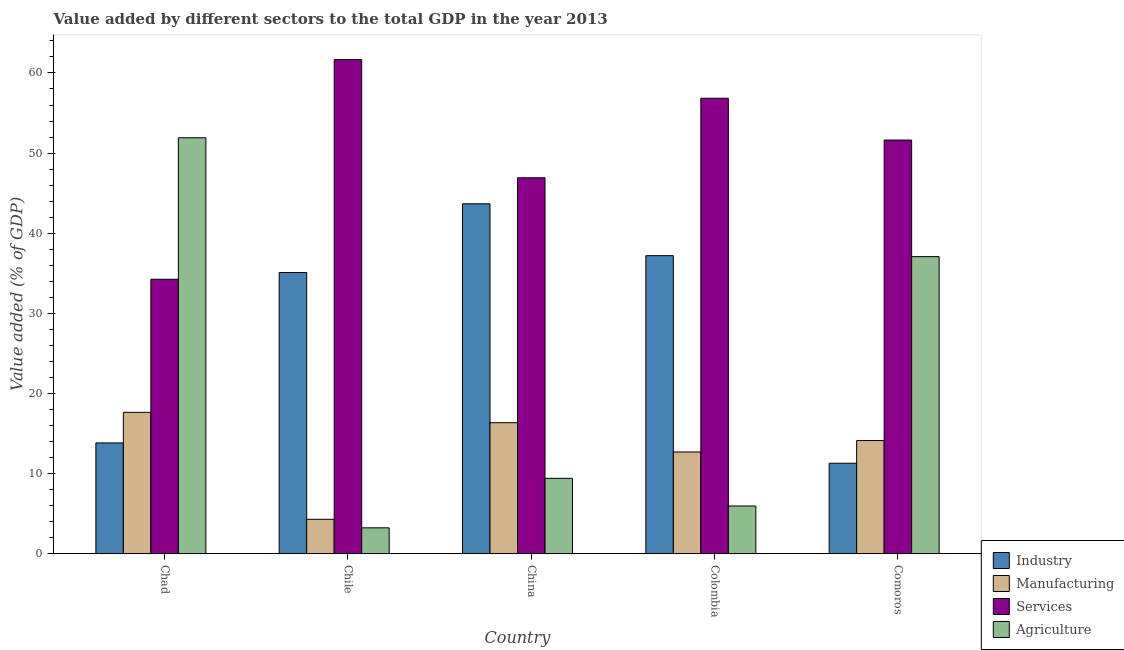How many different coloured bars are there?
Your answer should be very brief. 4. How many groups of bars are there?
Make the answer very short. 5. Are the number of bars per tick equal to the number of legend labels?
Provide a short and direct response. Yes. Are the number of bars on each tick of the X-axis equal?
Your answer should be very brief. Yes. How many bars are there on the 5th tick from the left?
Give a very brief answer. 4. How many bars are there on the 1st tick from the right?
Your response must be concise. 4. What is the value added by services sector in Comoros?
Your answer should be compact. 51.63. Across all countries, what is the maximum value added by services sector?
Keep it short and to the point. 61.67. Across all countries, what is the minimum value added by industrial sector?
Keep it short and to the point. 11.29. In which country was the value added by manufacturing sector maximum?
Provide a short and direct response. Chad. In which country was the value added by services sector minimum?
Give a very brief answer. Chad. What is the total value added by industrial sector in the graph?
Your response must be concise. 141.09. What is the difference between the value added by services sector in Chad and that in Comoros?
Your response must be concise. -17.37. What is the difference between the value added by agricultural sector in China and the value added by industrial sector in Comoros?
Offer a very short reply. -1.88. What is the average value added by manufacturing sector per country?
Ensure brevity in your answer.  13.02. What is the difference between the value added by agricultural sector and value added by manufacturing sector in Colombia?
Your answer should be compact. -6.74. What is the ratio of the value added by agricultural sector in Chile to that in Colombia?
Your answer should be compact. 0.54. Is the difference between the value added by manufacturing sector in China and Comoros greater than the difference between the value added by services sector in China and Comoros?
Your response must be concise. Yes. What is the difference between the highest and the second highest value added by services sector?
Provide a succinct answer. 4.83. What is the difference between the highest and the lowest value added by services sector?
Offer a terse response. 27.42. In how many countries, is the value added by manufacturing sector greater than the average value added by manufacturing sector taken over all countries?
Offer a terse response. 3. What does the 2nd bar from the left in Chad represents?
Give a very brief answer. Manufacturing. What does the 2nd bar from the right in Chad represents?
Ensure brevity in your answer.  Services. Is it the case that in every country, the sum of the value added by industrial sector and value added by manufacturing sector is greater than the value added by services sector?
Provide a succinct answer. No. How many bars are there?
Make the answer very short. 20. Are all the bars in the graph horizontal?
Give a very brief answer. No. How many countries are there in the graph?
Provide a short and direct response. 5. What is the difference between two consecutive major ticks on the Y-axis?
Your answer should be very brief. 10. Does the graph contain any zero values?
Your answer should be very brief. No. Does the graph contain grids?
Make the answer very short. No. How are the legend labels stacked?
Provide a short and direct response. Vertical. What is the title of the graph?
Provide a succinct answer. Value added by different sectors to the total GDP in the year 2013. What is the label or title of the Y-axis?
Offer a terse response. Value added (% of GDP). What is the Value added (% of GDP) of Industry in Chad?
Your answer should be very brief. 13.83. What is the Value added (% of GDP) in Manufacturing in Chad?
Provide a succinct answer. 17.65. What is the Value added (% of GDP) of Services in Chad?
Your answer should be very brief. 34.25. What is the Value added (% of GDP) in Agriculture in Chad?
Provide a short and direct response. 51.92. What is the Value added (% of GDP) of Industry in Chile?
Your answer should be compact. 35.1. What is the Value added (% of GDP) in Manufacturing in Chile?
Offer a terse response. 4.3. What is the Value added (% of GDP) of Services in Chile?
Offer a very short reply. 61.67. What is the Value added (% of GDP) in Agriculture in Chile?
Your answer should be compact. 3.23. What is the Value added (% of GDP) of Industry in China?
Give a very brief answer. 43.67. What is the Value added (% of GDP) in Manufacturing in China?
Provide a short and direct response. 16.35. What is the Value added (% of GDP) in Services in China?
Provide a short and direct response. 46.92. What is the Value added (% of GDP) in Agriculture in China?
Your answer should be very brief. 9.41. What is the Value added (% of GDP) of Industry in Colombia?
Ensure brevity in your answer.  37.2. What is the Value added (% of GDP) of Manufacturing in Colombia?
Your answer should be very brief. 12.7. What is the Value added (% of GDP) of Services in Colombia?
Keep it short and to the point. 56.84. What is the Value added (% of GDP) in Agriculture in Colombia?
Offer a very short reply. 5.96. What is the Value added (% of GDP) in Industry in Comoros?
Give a very brief answer. 11.29. What is the Value added (% of GDP) of Manufacturing in Comoros?
Ensure brevity in your answer.  14.12. What is the Value added (% of GDP) of Services in Comoros?
Give a very brief answer. 51.63. What is the Value added (% of GDP) of Agriculture in Comoros?
Keep it short and to the point. 37.08. Across all countries, what is the maximum Value added (% of GDP) in Industry?
Ensure brevity in your answer.  43.67. Across all countries, what is the maximum Value added (% of GDP) of Manufacturing?
Keep it short and to the point. 17.65. Across all countries, what is the maximum Value added (% of GDP) of Services?
Provide a succinct answer. 61.67. Across all countries, what is the maximum Value added (% of GDP) in Agriculture?
Your answer should be very brief. 51.92. Across all countries, what is the minimum Value added (% of GDP) of Industry?
Provide a succinct answer. 11.29. Across all countries, what is the minimum Value added (% of GDP) in Manufacturing?
Your response must be concise. 4.3. Across all countries, what is the minimum Value added (% of GDP) in Services?
Ensure brevity in your answer.  34.25. Across all countries, what is the minimum Value added (% of GDP) in Agriculture?
Give a very brief answer. 3.23. What is the total Value added (% of GDP) in Industry in the graph?
Ensure brevity in your answer.  141.09. What is the total Value added (% of GDP) of Manufacturing in the graph?
Give a very brief answer. 65.12. What is the total Value added (% of GDP) of Services in the graph?
Give a very brief answer. 251.31. What is the total Value added (% of GDP) of Agriculture in the graph?
Give a very brief answer. 107.6. What is the difference between the Value added (% of GDP) in Industry in Chad and that in Chile?
Provide a short and direct response. -21.27. What is the difference between the Value added (% of GDP) of Manufacturing in Chad and that in Chile?
Provide a short and direct response. 13.35. What is the difference between the Value added (% of GDP) in Services in Chad and that in Chile?
Make the answer very short. -27.42. What is the difference between the Value added (% of GDP) in Agriculture in Chad and that in Chile?
Offer a terse response. 48.68. What is the difference between the Value added (% of GDP) in Industry in Chad and that in China?
Provide a succinct answer. -29.85. What is the difference between the Value added (% of GDP) of Manufacturing in Chad and that in China?
Offer a terse response. 1.3. What is the difference between the Value added (% of GDP) in Services in Chad and that in China?
Your answer should be compact. -12.66. What is the difference between the Value added (% of GDP) of Agriculture in Chad and that in China?
Keep it short and to the point. 42.51. What is the difference between the Value added (% of GDP) in Industry in Chad and that in Colombia?
Ensure brevity in your answer.  -23.37. What is the difference between the Value added (% of GDP) in Manufacturing in Chad and that in Colombia?
Your response must be concise. 4.95. What is the difference between the Value added (% of GDP) of Services in Chad and that in Colombia?
Keep it short and to the point. -22.59. What is the difference between the Value added (% of GDP) of Agriculture in Chad and that in Colombia?
Provide a short and direct response. 45.96. What is the difference between the Value added (% of GDP) of Industry in Chad and that in Comoros?
Offer a very short reply. 2.54. What is the difference between the Value added (% of GDP) in Manufacturing in Chad and that in Comoros?
Offer a terse response. 3.52. What is the difference between the Value added (% of GDP) of Services in Chad and that in Comoros?
Offer a terse response. -17.37. What is the difference between the Value added (% of GDP) of Agriculture in Chad and that in Comoros?
Offer a terse response. 14.84. What is the difference between the Value added (% of GDP) of Industry in Chile and that in China?
Keep it short and to the point. -8.58. What is the difference between the Value added (% of GDP) in Manufacturing in Chile and that in China?
Keep it short and to the point. -12.06. What is the difference between the Value added (% of GDP) in Services in Chile and that in China?
Offer a terse response. 14.75. What is the difference between the Value added (% of GDP) of Agriculture in Chile and that in China?
Provide a succinct answer. -6.18. What is the difference between the Value added (% of GDP) in Industry in Chile and that in Colombia?
Make the answer very short. -2.1. What is the difference between the Value added (% of GDP) in Manufacturing in Chile and that in Colombia?
Provide a succinct answer. -8.4. What is the difference between the Value added (% of GDP) in Services in Chile and that in Colombia?
Your response must be concise. 4.83. What is the difference between the Value added (% of GDP) in Agriculture in Chile and that in Colombia?
Your answer should be compact. -2.73. What is the difference between the Value added (% of GDP) of Industry in Chile and that in Comoros?
Your response must be concise. 23.8. What is the difference between the Value added (% of GDP) in Manufacturing in Chile and that in Comoros?
Make the answer very short. -9.83. What is the difference between the Value added (% of GDP) of Services in Chile and that in Comoros?
Your answer should be compact. 10.04. What is the difference between the Value added (% of GDP) of Agriculture in Chile and that in Comoros?
Provide a short and direct response. -33.85. What is the difference between the Value added (% of GDP) of Industry in China and that in Colombia?
Your answer should be very brief. 6.48. What is the difference between the Value added (% of GDP) of Manufacturing in China and that in Colombia?
Provide a short and direct response. 3.65. What is the difference between the Value added (% of GDP) of Services in China and that in Colombia?
Keep it short and to the point. -9.93. What is the difference between the Value added (% of GDP) in Agriculture in China and that in Colombia?
Offer a very short reply. 3.45. What is the difference between the Value added (% of GDP) in Industry in China and that in Comoros?
Make the answer very short. 32.38. What is the difference between the Value added (% of GDP) in Manufacturing in China and that in Comoros?
Your response must be concise. 2.23. What is the difference between the Value added (% of GDP) in Services in China and that in Comoros?
Make the answer very short. -4.71. What is the difference between the Value added (% of GDP) in Agriculture in China and that in Comoros?
Make the answer very short. -27.67. What is the difference between the Value added (% of GDP) in Industry in Colombia and that in Comoros?
Keep it short and to the point. 25.9. What is the difference between the Value added (% of GDP) of Manufacturing in Colombia and that in Comoros?
Keep it short and to the point. -1.42. What is the difference between the Value added (% of GDP) of Services in Colombia and that in Comoros?
Your answer should be compact. 5.21. What is the difference between the Value added (% of GDP) of Agriculture in Colombia and that in Comoros?
Offer a terse response. -31.12. What is the difference between the Value added (% of GDP) of Industry in Chad and the Value added (% of GDP) of Manufacturing in Chile?
Give a very brief answer. 9.53. What is the difference between the Value added (% of GDP) of Industry in Chad and the Value added (% of GDP) of Services in Chile?
Offer a very short reply. -47.84. What is the difference between the Value added (% of GDP) of Industry in Chad and the Value added (% of GDP) of Agriculture in Chile?
Give a very brief answer. 10.6. What is the difference between the Value added (% of GDP) of Manufacturing in Chad and the Value added (% of GDP) of Services in Chile?
Keep it short and to the point. -44.02. What is the difference between the Value added (% of GDP) in Manufacturing in Chad and the Value added (% of GDP) in Agriculture in Chile?
Your answer should be very brief. 14.41. What is the difference between the Value added (% of GDP) of Services in Chad and the Value added (% of GDP) of Agriculture in Chile?
Give a very brief answer. 31.02. What is the difference between the Value added (% of GDP) in Industry in Chad and the Value added (% of GDP) in Manufacturing in China?
Offer a very short reply. -2.52. What is the difference between the Value added (% of GDP) of Industry in Chad and the Value added (% of GDP) of Services in China?
Keep it short and to the point. -33.09. What is the difference between the Value added (% of GDP) in Industry in Chad and the Value added (% of GDP) in Agriculture in China?
Your response must be concise. 4.42. What is the difference between the Value added (% of GDP) in Manufacturing in Chad and the Value added (% of GDP) in Services in China?
Give a very brief answer. -29.27. What is the difference between the Value added (% of GDP) of Manufacturing in Chad and the Value added (% of GDP) of Agriculture in China?
Your answer should be compact. 8.24. What is the difference between the Value added (% of GDP) of Services in Chad and the Value added (% of GDP) of Agriculture in China?
Ensure brevity in your answer.  24.85. What is the difference between the Value added (% of GDP) of Industry in Chad and the Value added (% of GDP) of Manufacturing in Colombia?
Offer a very short reply. 1.13. What is the difference between the Value added (% of GDP) of Industry in Chad and the Value added (% of GDP) of Services in Colombia?
Your response must be concise. -43.01. What is the difference between the Value added (% of GDP) in Industry in Chad and the Value added (% of GDP) in Agriculture in Colombia?
Give a very brief answer. 7.87. What is the difference between the Value added (% of GDP) in Manufacturing in Chad and the Value added (% of GDP) in Services in Colombia?
Keep it short and to the point. -39.2. What is the difference between the Value added (% of GDP) in Manufacturing in Chad and the Value added (% of GDP) in Agriculture in Colombia?
Offer a very short reply. 11.69. What is the difference between the Value added (% of GDP) of Services in Chad and the Value added (% of GDP) of Agriculture in Colombia?
Make the answer very short. 28.29. What is the difference between the Value added (% of GDP) of Industry in Chad and the Value added (% of GDP) of Manufacturing in Comoros?
Your answer should be compact. -0.3. What is the difference between the Value added (% of GDP) of Industry in Chad and the Value added (% of GDP) of Services in Comoros?
Keep it short and to the point. -37.8. What is the difference between the Value added (% of GDP) of Industry in Chad and the Value added (% of GDP) of Agriculture in Comoros?
Keep it short and to the point. -23.25. What is the difference between the Value added (% of GDP) of Manufacturing in Chad and the Value added (% of GDP) of Services in Comoros?
Offer a terse response. -33.98. What is the difference between the Value added (% of GDP) of Manufacturing in Chad and the Value added (% of GDP) of Agriculture in Comoros?
Make the answer very short. -19.43. What is the difference between the Value added (% of GDP) in Services in Chad and the Value added (% of GDP) in Agriculture in Comoros?
Keep it short and to the point. -2.82. What is the difference between the Value added (% of GDP) in Industry in Chile and the Value added (% of GDP) in Manufacturing in China?
Your answer should be compact. 18.75. What is the difference between the Value added (% of GDP) of Industry in Chile and the Value added (% of GDP) of Services in China?
Provide a succinct answer. -11.82. What is the difference between the Value added (% of GDP) in Industry in Chile and the Value added (% of GDP) in Agriculture in China?
Make the answer very short. 25.69. What is the difference between the Value added (% of GDP) of Manufacturing in Chile and the Value added (% of GDP) of Services in China?
Give a very brief answer. -42.62. What is the difference between the Value added (% of GDP) in Manufacturing in Chile and the Value added (% of GDP) in Agriculture in China?
Your response must be concise. -5.11. What is the difference between the Value added (% of GDP) in Services in Chile and the Value added (% of GDP) in Agriculture in China?
Make the answer very short. 52.26. What is the difference between the Value added (% of GDP) of Industry in Chile and the Value added (% of GDP) of Manufacturing in Colombia?
Your answer should be compact. 22.4. What is the difference between the Value added (% of GDP) in Industry in Chile and the Value added (% of GDP) in Services in Colombia?
Make the answer very short. -21.75. What is the difference between the Value added (% of GDP) of Industry in Chile and the Value added (% of GDP) of Agriculture in Colombia?
Your answer should be very brief. 29.14. What is the difference between the Value added (% of GDP) in Manufacturing in Chile and the Value added (% of GDP) in Services in Colombia?
Offer a very short reply. -52.55. What is the difference between the Value added (% of GDP) of Manufacturing in Chile and the Value added (% of GDP) of Agriculture in Colombia?
Keep it short and to the point. -1.66. What is the difference between the Value added (% of GDP) in Services in Chile and the Value added (% of GDP) in Agriculture in Colombia?
Offer a terse response. 55.71. What is the difference between the Value added (% of GDP) of Industry in Chile and the Value added (% of GDP) of Manufacturing in Comoros?
Keep it short and to the point. 20.97. What is the difference between the Value added (% of GDP) in Industry in Chile and the Value added (% of GDP) in Services in Comoros?
Offer a very short reply. -16.53. What is the difference between the Value added (% of GDP) in Industry in Chile and the Value added (% of GDP) in Agriculture in Comoros?
Offer a very short reply. -1.98. What is the difference between the Value added (% of GDP) of Manufacturing in Chile and the Value added (% of GDP) of Services in Comoros?
Provide a short and direct response. -47.33. What is the difference between the Value added (% of GDP) of Manufacturing in Chile and the Value added (% of GDP) of Agriculture in Comoros?
Your response must be concise. -32.78. What is the difference between the Value added (% of GDP) of Services in Chile and the Value added (% of GDP) of Agriculture in Comoros?
Give a very brief answer. 24.59. What is the difference between the Value added (% of GDP) of Industry in China and the Value added (% of GDP) of Manufacturing in Colombia?
Make the answer very short. 30.97. What is the difference between the Value added (% of GDP) in Industry in China and the Value added (% of GDP) in Services in Colombia?
Provide a succinct answer. -13.17. What is the difference between the Value added (% of GDP) in Industry in China and the Value added (% of GDP) in Agriculture in Colombia?
Offer a very short reply. 37.71. What is the difference between the Value added (% of GDP) in Manufacturing in China and the Value added (% of GDP) in Services in Colombia?
Make the answer very short. -40.49. What is the difference between the Value added (% of GDP) in Manufacturing in China and the Value added (% of GDP) in Agriculture in Colombia?
Give a very brief answer. 10.39. What is the difference between the Value added (% of GDP) in Services in China and the Value added (% of GDP) in Agriculture in Colombia?
Offer a very short reply. 40.96. What is the difference between the Value added (% of GDP) in Industry in China and the Value added (% of GDP) in Manufacturing in Comoros?
Offer a terse response. 29.55. What is the difference between the Value added (% of GDP) of Industry in China and the Value added (% of GDP) of Services in Comoros?
Provide a short and direct response. -7.95. What is the difference between the Value added (% of GDP) of Industry in China and the Value added (% of GDP) of Agriculture in Comoros?
Provide a succinct answer. 6.59. What is the difference between the Value added (% of GDP) in Manufacturing in China and the Value added (% of GDP) in Services in Comoros?
Your answer should be very brief. -35.28. What is the difference between the Value added (% of GDP) of Manufacturing in China and the Value added (% of GDP) of Agriculture in Comoros?
Provide a succinct answer. -20.73. What is the difference between the Value added (% of GDP) of Services in China and the Value added (% of GDP) of Agriculture in Comoros?
Offer a terse response. 9.84. What is the difference between the Value added (% of GDP) of Industry in Colombia and the Value added (% of GDP) of Manufacturing in Comoros?
Provide a succinct answer. 23.07. What is the difference between the Value added (% of GDP) of Industry in Colombia and the Value added (% of GDP) of Services in Comoros?
Make the answer very short. -14.43. What is the difference between the Value added (% of GDP) in Industry in Colombia and the Value added (% of GDP) in Agriculture in Comoros?
Make the answer very short. 0.12. What is the difference between the Value added (% of GDP) in Manufacturing in Colombia and the Value added (% of GDP) in Services in Comoros?
Provide a succinct answer. -38.93. What is the difference between the Value added (% of GDP) of Manufacturing in Colombia and the Value added (% of GDP) of Agriculture in Comoros?
Give a very brief answer. -24.38. What is the difference between the Value added (% of GDP) of Services in Colombia and the Value added (% of GDP) of Agriculture in Comoros?
Your answer should be compact. 19.76. What is the average Value added (% of GDP) in Industry per country?
Provide a succinct answer. 28.22. What is the average Value added (% of GDP) in Manufacturing per country?
Ensure brevity in your answer.  13.02. What is the average Value added (% of GDP) in Services per country?
Your answer should be compact. 50.26. What is the average Value added (% of GDP) of Agriculture per country?
Provide a succinct answer. 21.52. What is the difference between the Value added (% of GDP) of Industry and Value added (% of GDP) of Manufacturing in Chad?
Offer a terse response. -3.82. What is the difference between the Value added (% of GDP) of Industry and Value added (% of GDP) of Services in Chad?
Offer a terse response. -20.43. What is the difference between the Value added (% of GDP) of Industry and Value added (% of GDP) of Agriculture in Chad?
Provide a short and direct response. -38.09. What is the difference between the Value added (% of GDP) in Manufacturing and Value added (% of GDP) in Services in Chad?
Your answer should be compact. -16.61. What is the difference between the Value added (% of GDP) in Manufacturing and Value added (% of GDP) in Agriculture in Chad?
Make the answer very short. -34.27. What is the difference between the Value added (% of GDP) in Services and Value added (% of GDP) in Agriculture in Chad?
Offer a very short reply. -17.66. What is the difference between the Value added (% of GDP) of Industry and Value added (% of GDP) of Manufacturing in Chile?
Your response must be concise. 30.8. What is the difference between the Value added (% of GDP) in Industry and Value added (% of GDP) in Services in Chile?
Make the answer very short. -26.57. What is the difference between the Value added (% of GDP) of Industry and Value added (% of GDP) of Agriculture in Chile?
Provide a succinct answer. 31.86. What is the difference between the Value added (% of GDP) in Manufacturing and Value added (% of GDP) in Services in Chile?
Give a very brief answer. -57.37. What is the difference between the Value added (% of GDP) in Manufacturing and Value added (% of GDP) in Agriculture in Chile?
Give a very brief answer. 1.06. What is the difference between the Value added (% of GDP) in Services and Value added (% of GDP) in Agriculture in Chile?
Your response must be concise. 58.44. What is the difference between the Value added (% of GDP) in Industry and Value added (% of GDP) in Manufacturing in China?
Ensure brevity in your answer.  27.32. What is the difference between the Value added (% of GDP) in Industry and Value added (% of GDP) in Services in China?
Your answer should be very brief. -3.24. What is the difference between the Value added (% of GDP) of Industry and Value added (% of GDP) of Agriculture in China?
Ensure brevity in your answer.  34.27. What is the difference between the Value added (% of GDP) in Manufacturing and Value added (% of GDP) in Services in China?
Keep it short and to the point. -30.57. What is the difference between the Value added (% of GDP) in Manufacturing and Value added (% of GDP) in Agriculture in China?
Keep it short and to the point. 6.94. What is the difference between the Value added (% of GDP) in Services and Value added (% of GDP) in Agriculture in China?
Give a very brief answer. 37.51. What is the difference between the Value added (% of GDP) of Industry and Value added (% of GDP) of Manufacturing in Colombia?
Make the answer very short. 24.5. What is the difference between the Value added (% of GDP) in Industry and Value added (% of GDP) in Services in Colombia?
Keep it short and to the point. -19.65. What is the difference between the Value added (% of GDP) in Industry and Value added (% of GDP) in Agriculture in Colombia?
Provide a succinct answer. 31.24. What is the difference between the Value added (% of GDP) in Manufacturing and Value added (% of GDP) in Services in Colombia?
Provide a succinct answer. -44.14. What is the difference between the Value added (% of GDP) of Manufacturing and Value added (% of GDP) of Agriculture in Colombia?
Your response must be concise. 6.74. What is the difference between the Value added (% of GDP) of Services and Value added (% of GDP) of Agriculture in Colombia?
Offer a terse response. 50.88. What is the difference between the Value added (% of GDP) in Industry and Value added (% of GDP) in Manufacturing in Comoros?
Offer a terse response. -2.83. What is the difference between the Value added (% of GDP) in Industry and Value added (% of GDP) in Services in Comoros?
Your answer should be very brief. -40.34. What is the difference between the Value added (% of GDP) of Industry and Value added (% of GDP) of Agriculture in Comoros?
Make the answer very short. -25.79. What is the difference between the Value added (% of GDP) of Manufacturing and Value added (% of GDP) of Services in Comoros?
Keep it short and to the point. -37.5. What is the difference between the Value added (% of GDP) in Manufacturing and Value added (% of GDP) in Agriculture in Comoros?
Your response must be concise. -22.95. What is the difference between the Value added (% of GDP) in Services and Value added (% of GDP) in Agriculture in Comoros?
Provide a short and direct response. 14.55. What is the ratio of the Value added (% of GDP) in Industry in Chad to that in Chile?
Your response must be concise. 0.39. What is the ratio of the Value added (% of GDP) of Manufacturing in Chad to that in Chile?
Ensure brevity in your answer.  4.11. What is the ratio of the Value added (% of GDP) in Services in Chad to that in Chile?
Give a very brief answer. 0.56. What is the ratio of the Value added (% of GDP) of Agriculture in Chad to that in Chile?
Your answer should be compact. 16.06. What is the ratio of the Value added (% of GDP) in Industry in Chad to that in China?
Your response must be concise. 0.32. What is the ratio of the Value added (% of GDP) of Manufacturing in Chad to that in China?
Your answer should be compact. 1.08. What is the ratio of the Value added (% of GDP) of Services in Chad to that in China?
Provide a short and direct response. 0.73. What is the ratio of the Value added (% of GDP) in Agriculture in Chad to that in China?
Give a very brief answer. 5.52. What is the ratio of the Value added (% of GDP) in Industry in Chad to that in Colombia?
Provide a short and direct response. 0.37. What is the ratio of the Value added (% of GDP) in Manufacturing in Chad to that in Colombia?
Your response must be concise. 1.39. What is the ratio of the Value added (% of GDP) of Services in Chad to that in Colombia?
Keep it short and to the point. 0.6. What is the ratio of the Value added (% of GDP) in Agriculture in Chad to that in Colombia?
Offer a very short reply. 8.71. What is the ratio of the Value added (% of GDP) of Industry in Chad to that in Comoros?
Your response must be concise. 1.22. What is the ratio of the Value added (% of GDP) of Manufacturing in Chad to that in Comoros?
Give a very brief answer. 1.25. What is the ratio of the Value added (% of GDP) in Services in Chad to that in Comoros?
Make the answer very short. 0.66. What is the ratio of the Value added (% of GDP) in Agriculture in Chad to that in Comoros?
Ensure brevity in your answer.  1.4. What is the ratio of the Value added (% of GDP) in Industry in Chile to that in China?
Your response must be concise. 0.8. What is the ratio of the Value added (% of GDP) in Manufacturing in Chile to that in China?
Provide a succinct answer. 0.26. What is the ratio of the Value added (% of GDP) in Services in Chile to that in China?
Your answer should be very brief. 1.31. What is the ratio of the Value added (% of GDP) of Agriculture in Chile to that in China?
Your answer should be very brief. 0.34. What is the ratio of the Value added (% of GDP) in Industry in Chile to that in Colombia?
Your answer should be compact. 0.94. What is the ratio of the Value added (% of GDP) of Manufacturing in Chile to that in Colombia?
Your response must be concise. 0.34. What is the ratio of the Value added (% of GDP) of Services in Chile to that in Colombia?
Offer a terse response. 1.08. What is the ratio of the Value added (% of GDP) of Agriculture in Chile to that in Colombia?
Provide a succinct answer. 0.54. What is the ratio of the Value added (% of GDP) of Industry in Chile to that in Comoros?
Give a very brief answer. 3.11. What is the ratio of the Value added (% of GDP) in Manufacturing in Chile to that in Comoros?
Make the answer very short. 0.3. What is the ratio of the Value added (% of GDP) in Services in Chile to that in Comoros?
Keep it short and to the point. 1.19. What is the ratio of the Value added (% of GDP) of Agriculture in Chile to that in Comoros?
Ensure brevity in your answer.  0.09. What is the ratio of the Value added (% of GDP) of Industry in China to that in Colombia?
Give a very brief answer. 1.17. What is the ratio of the Value added (% of GDP) in Manufacturing in China to that in Colombia?
Make the answer very short. 1.29. What is the ratio of the Value added (% of GDP) of Services in China to that in Colombia?
Ensure brevity in your answer.  0.83. What is the ratio of the Value added (% of GDP) in Agriculture in China to that in Colombia?
Your answer should be very brief. 1.58. What is the ratio of the Value added (% of GDP) in Industry in China to that in Comoros?
Your answer should be very brief. 3.87. What is the ratio of the Value added (% of GDP) in Manufacturing in China to that in Comoros?
Give a very brief answer. 1.16. What is the ratio of the Value added (% of GDP) in Services in China to that in Comoros?
Your response must be concise. 0.91. What is the ratio of the Value added (% of GDP) in Agriculture in China to that in Comoros?
Make the answer very short. 0.25. What is the ratio of the Value added (% of GDP) of Industry in Colombia to that in Comoros?
Make the answer very short. 3.29. What is the ratio of the Value added (% of GDP) in Manufacturing in Colombia to that in Comoros?
Offer a terse response. 0.9. What is the ratio of the Value added (% of GDP) in Services in Colombia to that in Comoros?
Provide a succinct answer. 1.1. What is the ratio of the Value added (% of GDP) in Agriculture in Colombia to that in Comoros?
Provide a succinct answer. 0.16. What is the difference between the highest and the second highest Value added (% of GDP) in Industry?
Give a very brief answer. 6.48. What is the difference between the highest and the second highest Value added (% of GDP) of Manufacturing?
Give a very brief answer. 1.3. What is the difference between the highest and the second highest Value added (% of GDP) in Services?
Provide a succinct answer. 4.83. What is the difference between the highest and the second highest Value added (% of GDP) of Agriculture?
Your answer should be very brief. 14.84. What is the difference between the highest and the lowest Value added (% of GDP) in Industry?
Make the answer very short. 32.38. What is the difference between the highest and the lowest Value added (% of GDP) in Manufacturing?
Make the answer very short. 13.35. What is the difference between the highest and the lowest Value added (% of GDP) of Services?
Your answer should be very brief. 27.42. What is the difference between the highest and the lowest Value added (% of GDP) in Agriculture?
Make the answer very short. 48.68. 